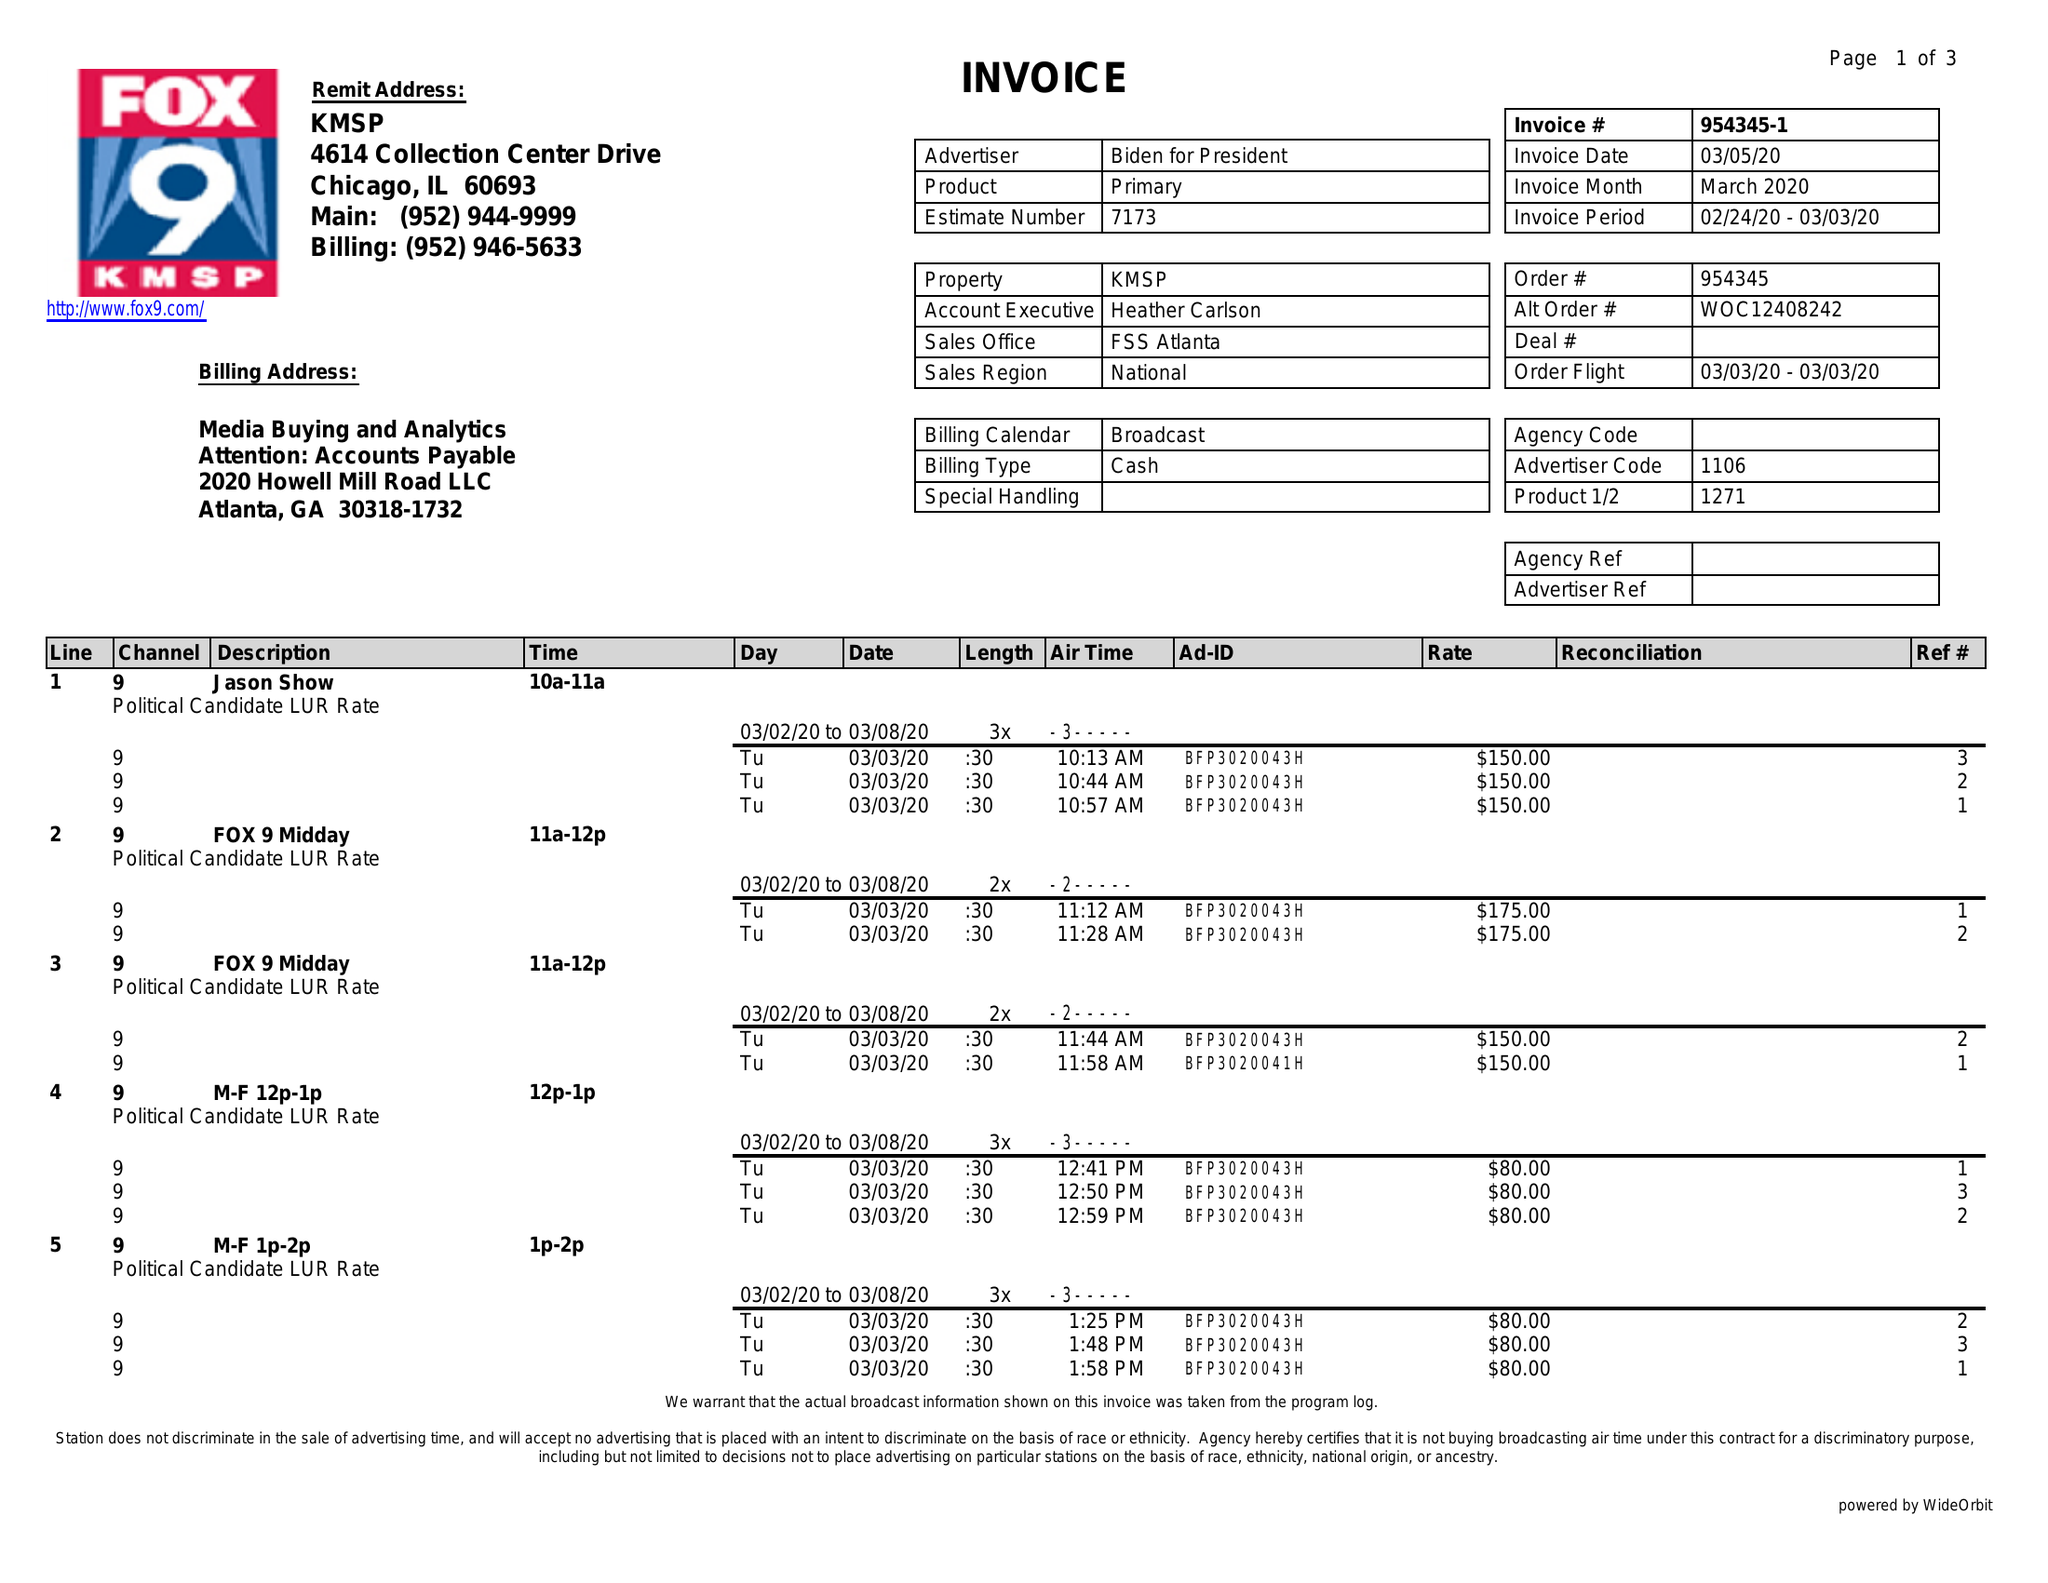What is the value for the flight_from?
Answer the question using a single word or phrase. 03/03/20 